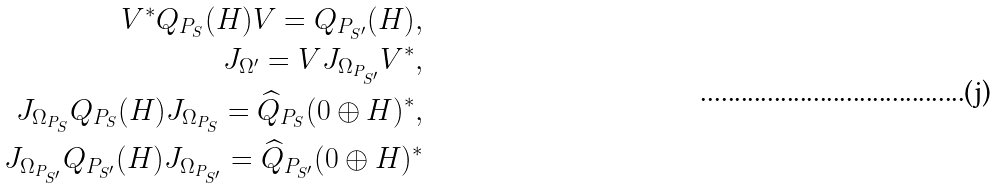Convert formula to latex. <formula><loc_0><loc_0><loc_500><loc_500>V ^ { * } Q _ { P _ { S } } ( H ) V = Q _ { P _ { S ^ { \prime } } } ( H ) , \\ J _ { \Omega ^ { \prime } } = V J _ { \Omega _ { P _ { S ^ { \prime } } } } V ^ { * } , \\ J _ { \Omega _ { P _ { S } } } Q _ { P _ { S } } ( H ) J _ { \Omega _ { P _ { S } } } = { \widehat { Q } } _ { P _ { S } } ( 0 \oplus H ) ^ { * } , \\ J _ { \Omega _ { P _ { S ^ { \prime } } } } Q _ { P _ { S ^ { \prime } } } ( H ) J _ { \Omega _ { P _ { S ^ { \prime } } } } = \widehat { Q } _ { P _ { S ^ { \prime } } } ( 0 \oplus H ) ^ { * }</formula> 